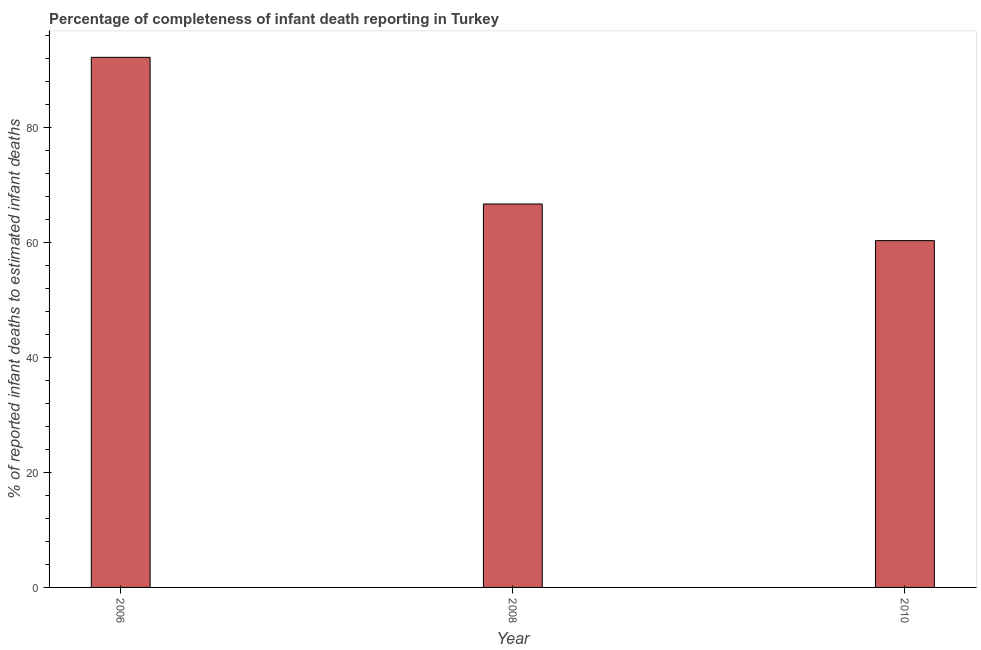Does the graph contain grids?
Keep it short and to the point. No. What is the title of the graph?
Provide a succinct answer. Percentage of completeness of infant death reporting in Turkey. What is the label or title of the X-axis?
Give a very brief answer. Year. What is the label or title of the Y-axis?
Provide a short and direct response. % of reported infant deaths to estimated infant deaths. What is the completeness of infant death reporting in 2008?
Your answer should be compact. 66.76. Across all years, what is the maximum completeness of infant death reporting?
Ensure brevity in your answer.  92.29. Across all years, what is the minimum completeness of infant death reporting?
Offer a terse response. 60.37. In which year was the completeness of infant death reporting minimum?
Keep it short and to the point. 2010. What is the sum of the completeness of infant death reporting?
Offer a terse response. 219.42. What is the difference between the completeness of infant death reporting in 2008 and 2010?
Make the answer very short. 6.38. What is the average completeness of infant death reporting per year?
Provide a succinct answer. 73.14. What is the median completeness of infant death reporting?
Offer a terse response. 66.76. In how many years, is the completeness of infant death reporting greater than 64 %?
Keep it short and to the point. 2. Do a majority of the years between 2008 and 2006 (inclusive) have completeness of infant death reporting greater than 60 %?
Offer a terse response. No. What is the ratio of the completeness of infant death reporting in 2006 to that in 2010?
Offer a very short reply. 1.53. What is the difference between the highest and the second highest completeness of infant death reporting?
Offer a terse response. 25.53. Is the sum of the completeness of infant death reporting in 2008 and 2010 greater than the maximum completeness of infant death reporting across all years?
Keep it short and to the point. Yes. What is the difference between the highest and the lowest completeness of infant death reporting?
Your response must be concise. 31.91. How many bars are there?
Ensure brevity in your answer.  3. Are all the bars in the graph horizontal?
Ensure brevity in your answer.  No. How many years are there in the graph?
Your response must be concise. 3. What is the difference between two consecutive major ticks on the Y-axis?
Your response must be concise. 20. Are the values on the major ticks of Y-axis written in scientific E-notation?
Give a very brief answer. No. What is the % of reported infant deaths to estimated infant deaths of 2006?
Keep it short and to the point. 92.29. What is the % of reported infant deaths to estimated infant deaths of 2008?
Give a very brief answer. 66.76. What is the % of reported infant deaths to estimated infant deaths in 2010?
Offer a terse response. 60.37. What is the difference between the % of reported infant deaths to estimated infant deaths in 2006 and 2008?
Give a very brief answer. 25.53. What is the difference between the % of reported infant deaths to estimated infant deaths in 2006 and 2010?
Your answer should be very brief. 31.91. What is the difference between the % of reported infant deaths to estimated infant deaths in 2008 and 2010?
Ensure brevity in your answer.  6.38. What is the ratio of the % of reported infant deaths to estimated infant deaths in 2006 to that in 2008?
Offer a very short reply. 1.38. What is the ratio of the % of reported infant deaths to estimated infant deaths in 2006 to that in 2010?
Give a very brief answer. 1.53. What is the ratio of the % of reported infant deaths to estimated infant deaths in 2008 to that in 2010?
Ensure brevity in your answer.  1.11. 